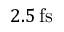<formula> <loc_0><loc_0><loc_500><loc_500>2 . 5 \, f s</formula> 